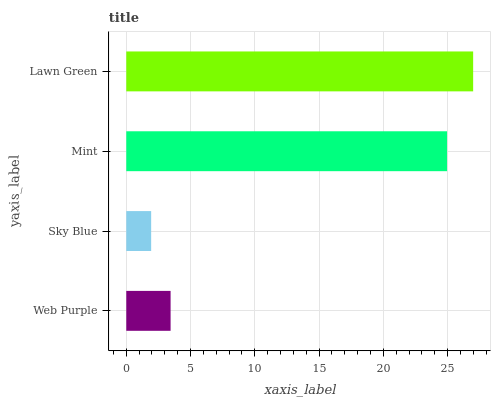Is Sky Blue the minimum?
Answer yes or no. Yes. Is Lawn Green the maximum?
Answer yes or no. Yes. Is Mint the minimum?
Answer yes or no. No. Is Mint the maximum?
Answer yes or no. No. Is Mint greater than Sky Blue?
Answer yes or no. Yes. Is Sky Blue less than Mint?
Answer yes or no. Yes. Is Sky Blue greater than Mint?
Answer yes or no. No. Is Mint less than Sky Blue?
Answer yes or no. No. Is Mint the high median?
Answer yes or no. Yes. Is Web Purple the low median?
Answer yes or no. Yes. Is Lawn Green the high median?
Answer yes or no. No. Is Lawn Green the low median?
Answer yes or no. No. 